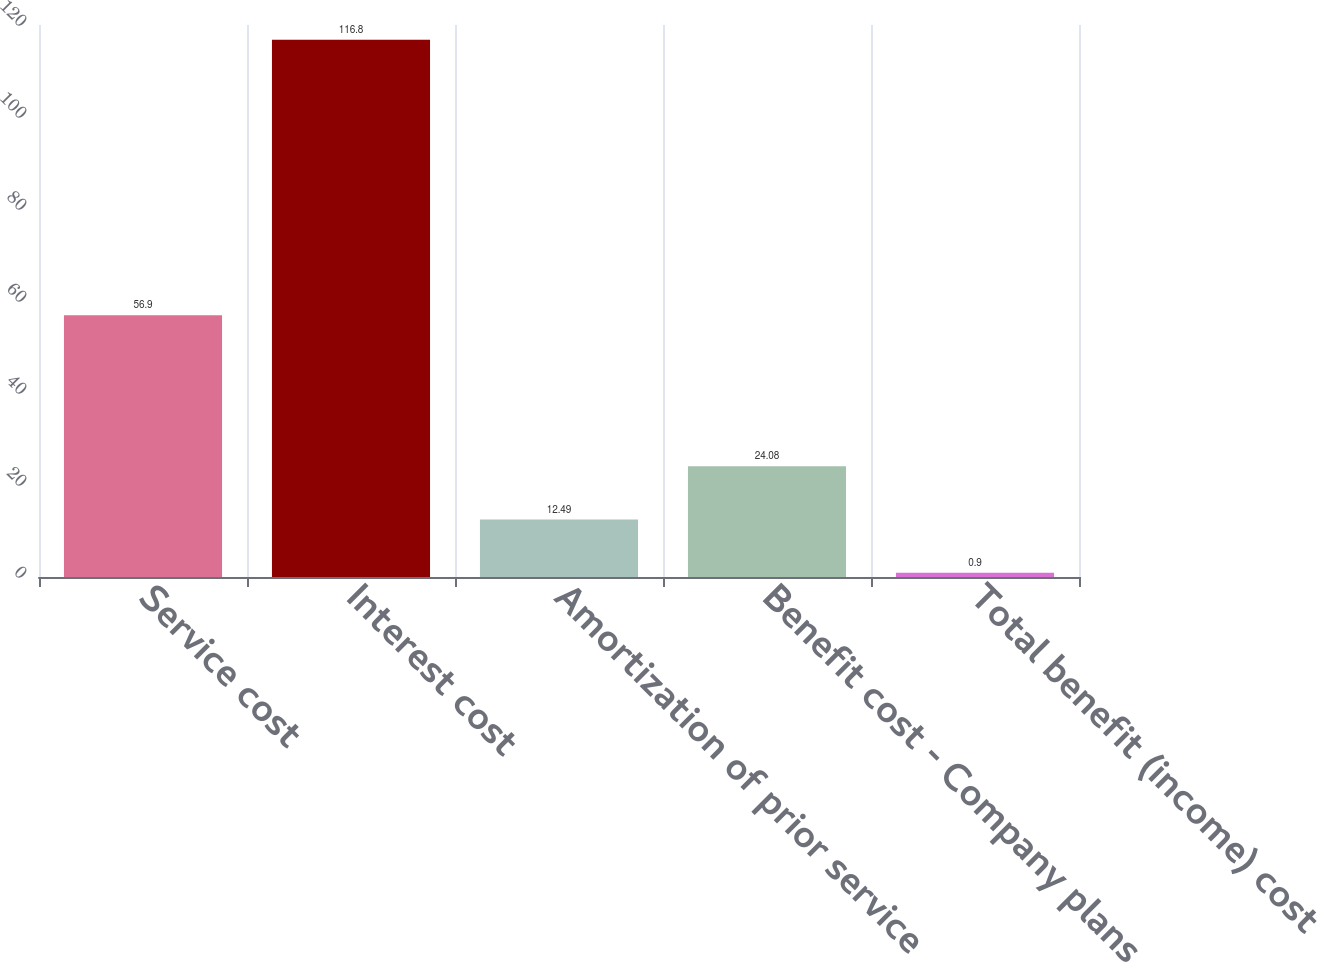Convert chart to OTSL. <chart><loc_0><loc_0><loc_500><loc_500><bar_chart><fcel>Service cost<fcel>Interest cost<fcel>Amortization of prior service<fcel>Benefit cost - Company plans<fcel>Total benefit (income) cost<nl><fcel>56.9<fcel>116.8<fcel>12.49<fcel>24.08<fcel>0.9<nl></chart> 